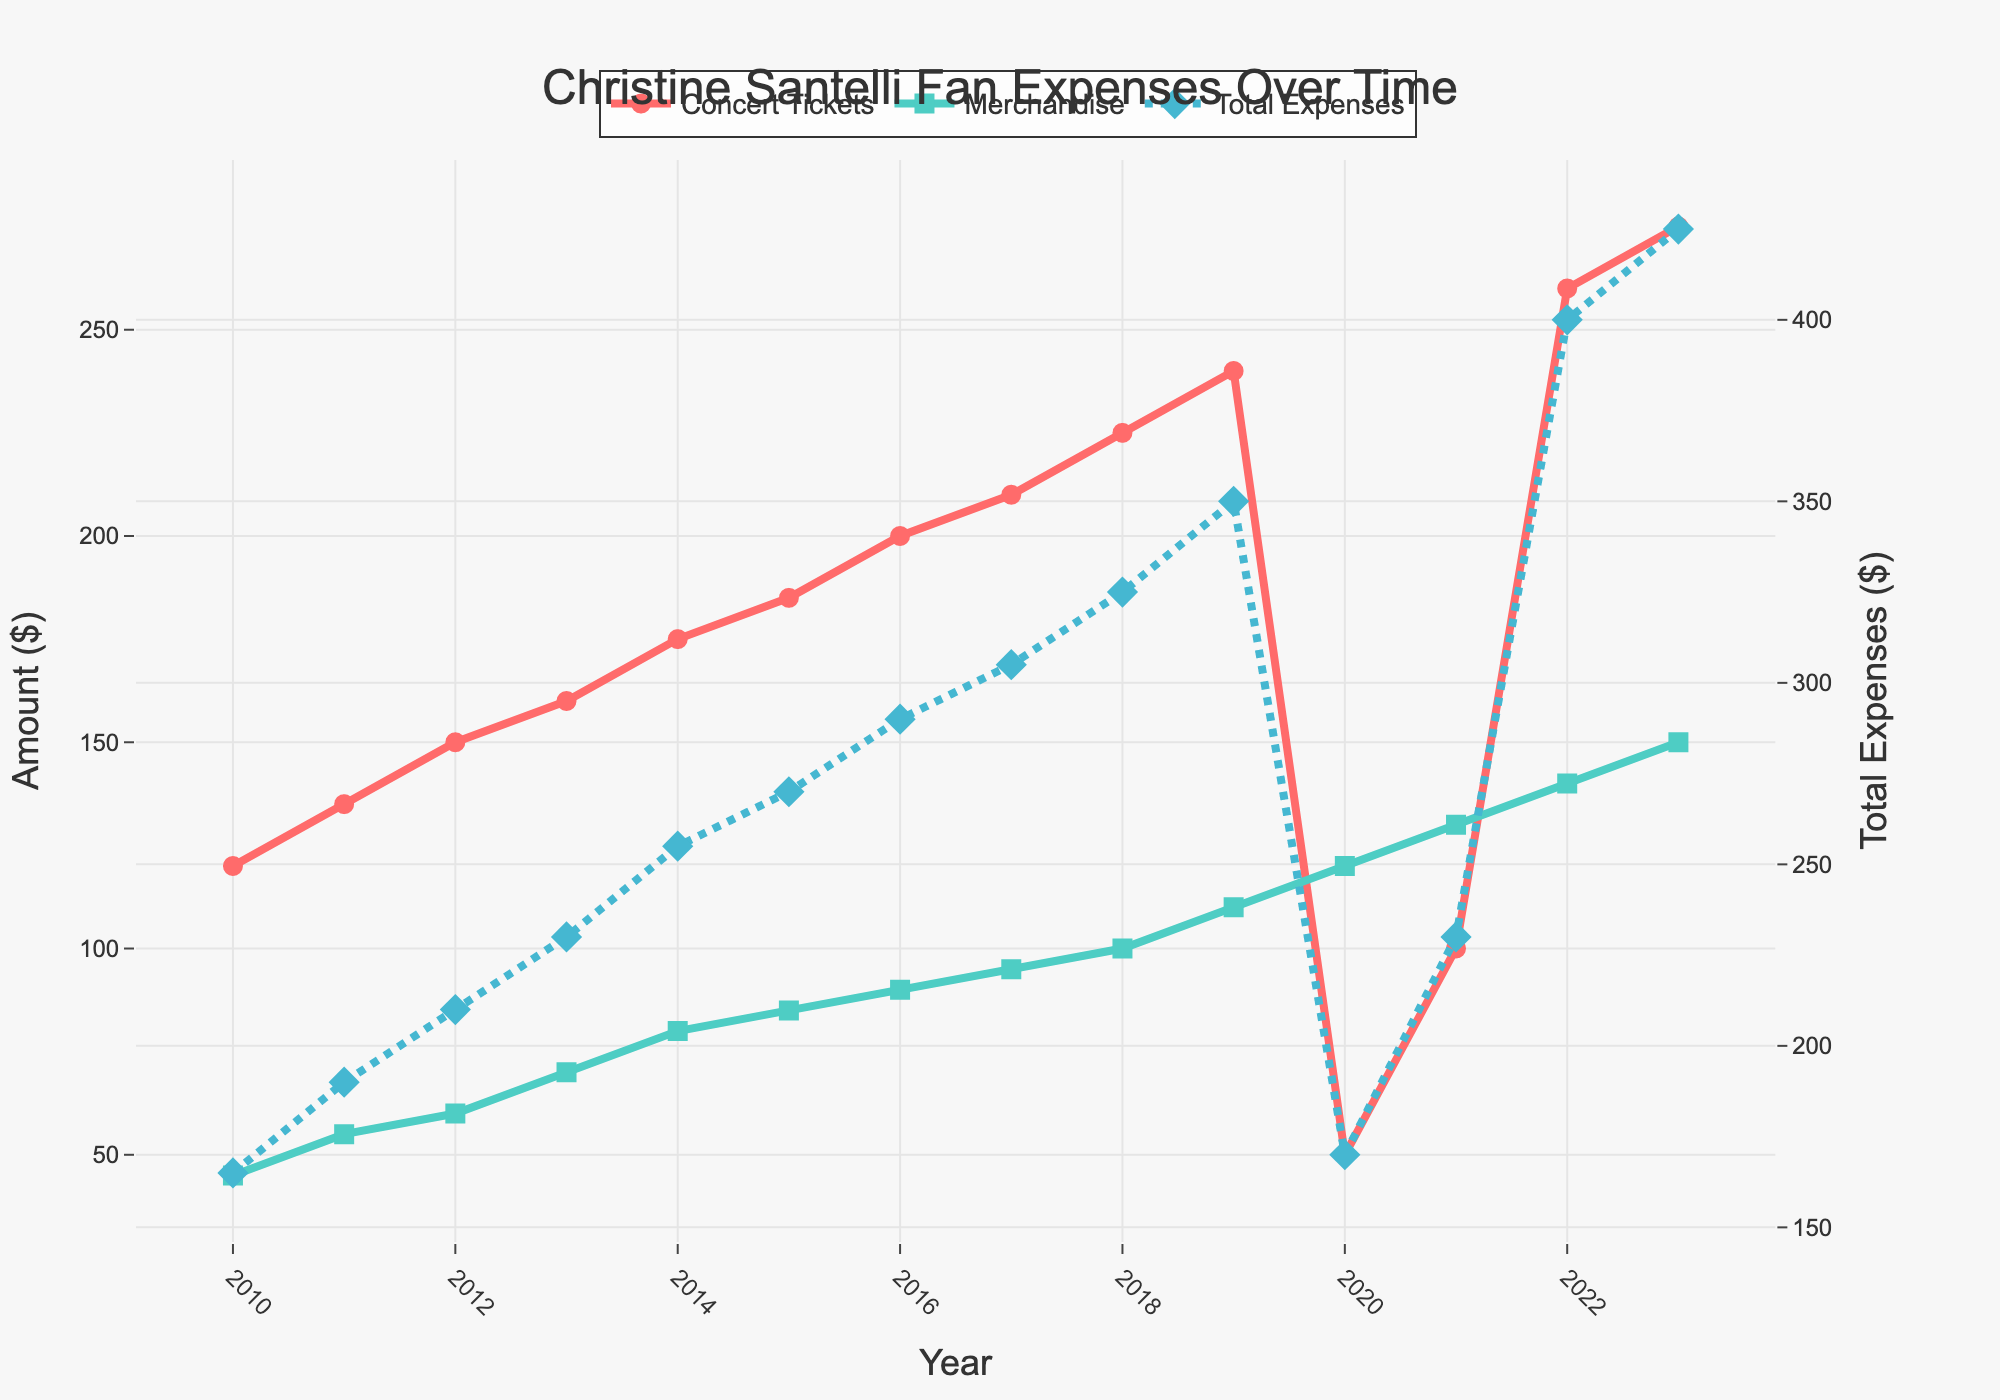What is the overall trend in concert ticket expenses from 2010 to 2023? By looking at the red line representing 'Concert Tickets', it moves upward consistently from 2010 to 2019, dips in 2020, then rises again through 2023.
Answer: Increasing, with a dip in 2020 Between which years did merchandise expenses increase the most? By examining the green line for 'Merchandise', the largest jump appears between 2019 and 2020.
Answer: 2019-2020 How much did total expenses increase from the lowest point to the highest point visible in the figure? The lowest 'Total Expenses' occurred in 2020 at $170, and the highest in 2023 at $425. Calculating the difference: 425 - 170 = 255.
Answer: $255 Which year had the lowest concert ticket expenses, and what were they? The red line dips to its lowest point in the year 2020, at $50.
Answer: 2020, $50 In which year did merchandise expenses reach $80? Looking at the green line, merchandise expenses hit $80 in the year 2014.
Answer: 2014 How do the concert ticket expenses in 2023 compare to those in 2010? The concert ticket expenses increased from $120 in 2010 to $275 in 2023, showing a rise of 275 - 120 = 155.
Answer: $155 increase What is the difference between merchandise expenses and concert ticket expenses in 2022? In 2022, the expenses were $140 for merchandise and $260 for concert tickets, so 260 - 140 = 120.
Answer: $120 What was the average yearly merchandise expense from 2010 to 2019? Sum the values from 2010 to 2019: (45 + 55 + 60 + 70 + 80 + 85 + 90 + 95 + 100 + 110) = 790. There are 10 years, so 790/10 = 79.
Answer: $79 Which expense category saw the biggest increase in 2021 compared to 2020? In 2021, 'Concert Tickets' increased from $50 to $100 (50), and 'Merchandise' increased from $120 to $130 (10). The largest increase was in 'Concert Tickets'.
Answer: Concert Tickets Are total expenses in 2018 and 2019 more or less than each of their combined concert ticket and merchandise expenses? For 2018: Total = 325, Concert + Merchandise = 225 + 100 = 325, they are equal. For 2019: Total = 350, Concert + Merchandise = 240 + 110 = 350, they are equal.
Answer: Equal in both years 